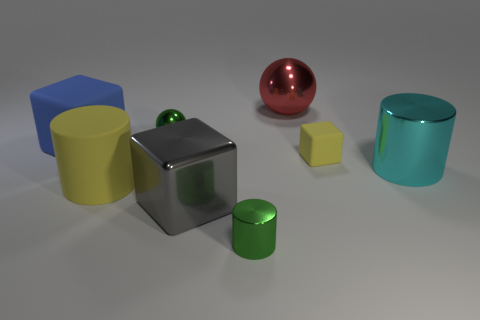Subtract all large metal cubes. How many cubes are left? 2 Add 1 big gray metal things. How many objects exist? 9 Subtract all blue cubes. How many cubes are left? 2 Subtract all blocks. How many objects are left? 5 Subtract all small green rubber cylinders. Subtract all matte objects. How many objects are left? 5 Add 1 green metallic objects. How many green metallic objects are left? 3 Add 3 small blocks. How many small blocks exist? 4 Subtract 1 blue cubes. How many objects are left? 7 Subtract 1 spheres. How many spheres are left? 1 Subtract all blue cylinders. Subtract all yellow spheres. How many cylinders are left? 3 